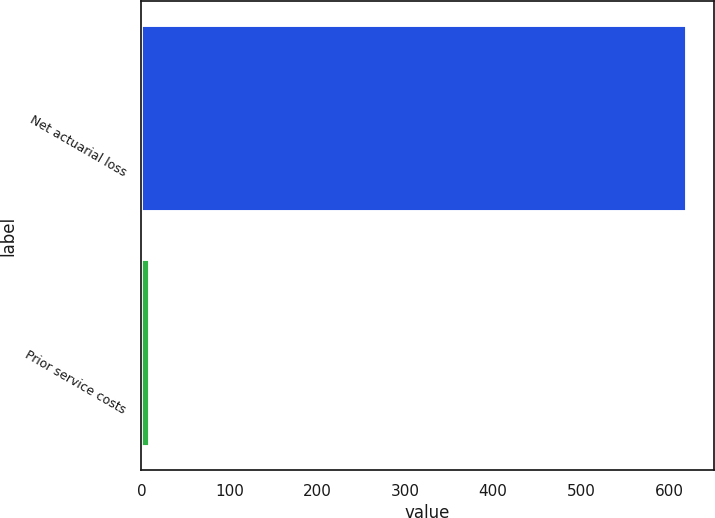Convert chart to OTSL. <chart><loc_0><loc_0><loc_500><loc_500><bar_chart><fcel>Net actuarial loss<fcel>Prior service costs<nl><fcel>620<fcel>10<nl></chart> 